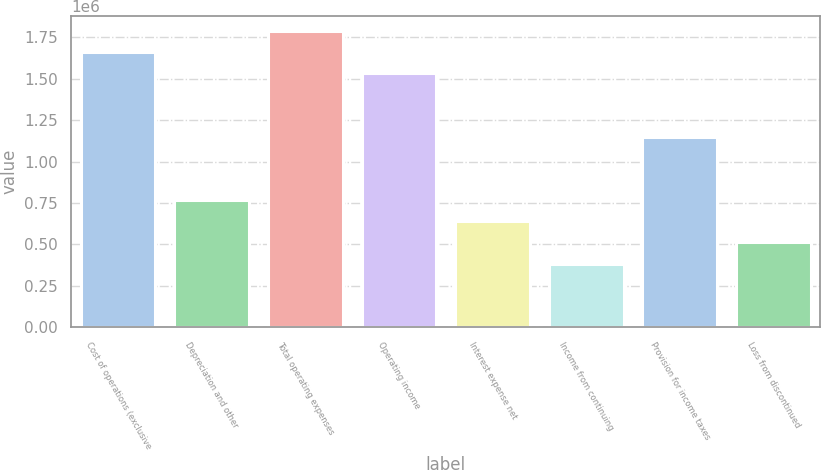<chart> <loc_0><loc_0><loc_500><loc_500><bar_chart><fcel>Cost of operations (exclusive<fcel>Depreciation and other<fcel>Total operating expenses<fcel>Operating income<fcel>Interest expense net<fcel>Income from continuing<fcel>Provision for income taxes<fcel>Loss from discontinued<nl><fcel>1.66032e+06<fcel>766302<fcel>1.78804e+06<fcel>1.5326e+06<fcel>638586<fcel>383152<fcel>1.14945e+06<fcel>510869<nl></chart> 